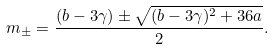Convert formula to latex. <formula><loc_0><loc_0><loc_500><loc_500>m _ { \pm } = \frac { ( b - 3 \gamma ) \pm \sqrt { ( b - 3 \gamma ) ^ { 2 } + 3 6 a } } { 2 } .</formula> 